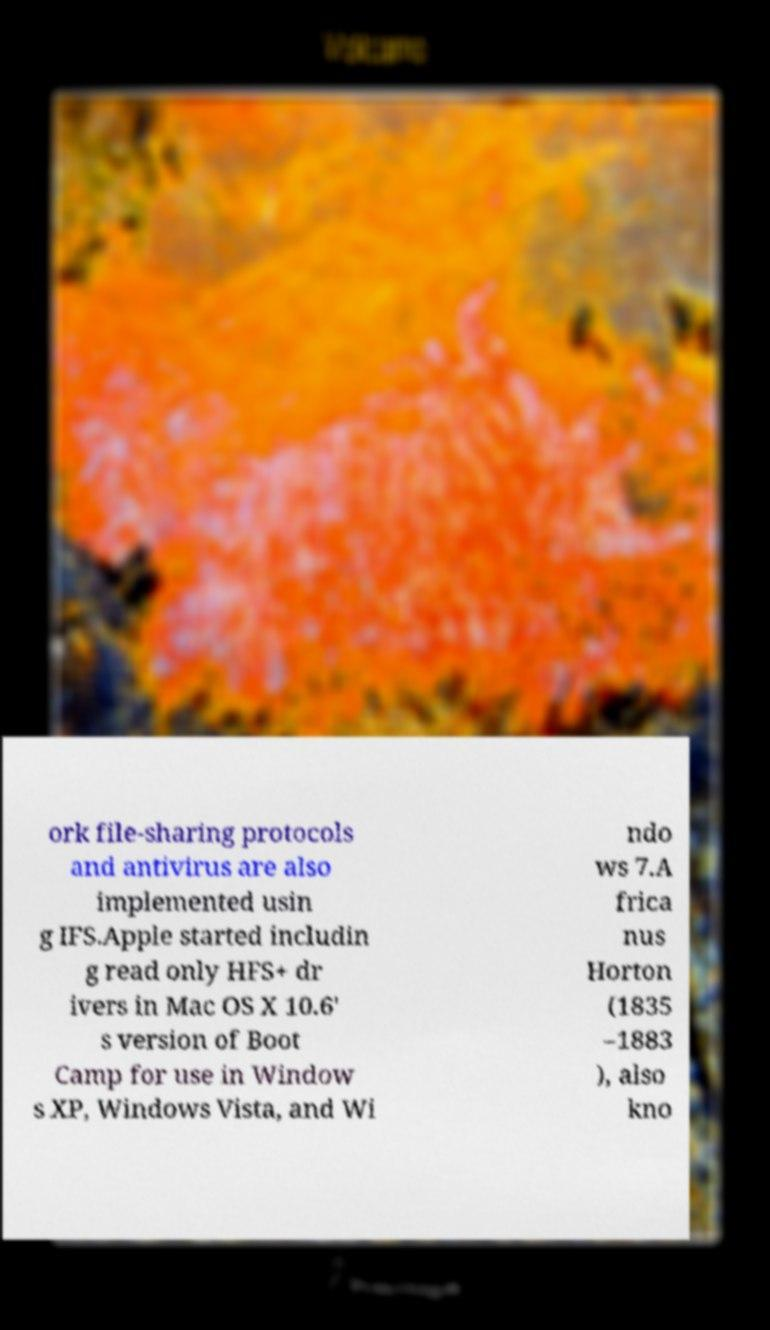There's text embedded in this image that I need extracted. Can you transcribe it verbatim? ork file-sharing protocols and antivirus are also implemented usin g IFS.Apple started includin g read only HFS+ dr ivers in Mac OS X 10.6' s version of Boot Camp for use in Window s XP, Windows Vista, and Wi ndo ws 7.A frica nus Horton (1835 –1883 ), also kno 